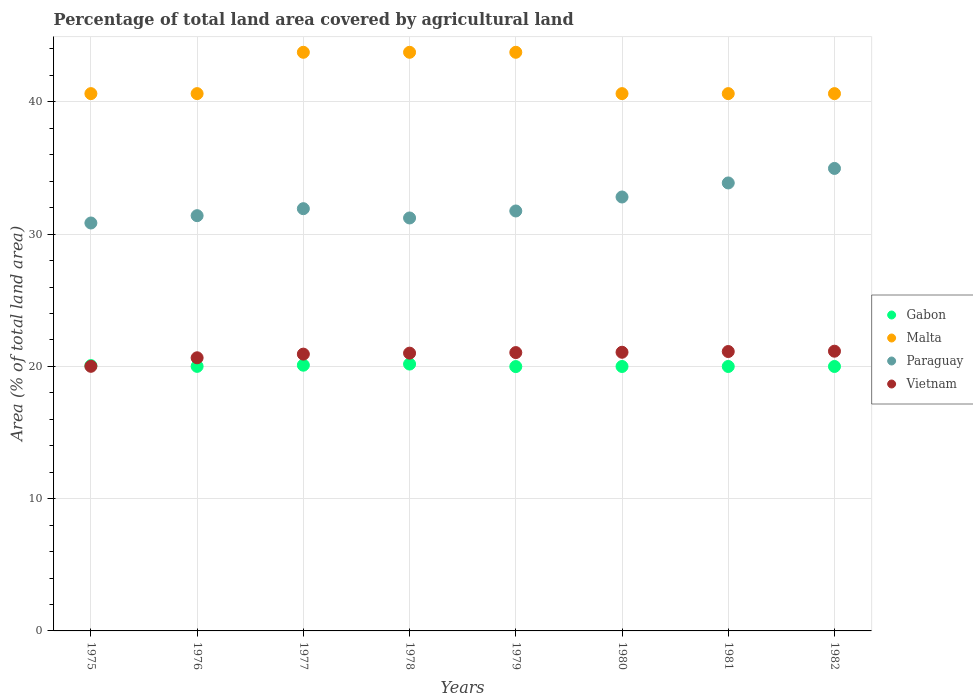How many different coloured dotlines are there?
Provide a succinct answer. 4. Is the number of dotlines equal to the number of legend labels?
Your response must be concise. Yes. What is the percentage of agricultural land in Paraguay in 1976?
Your answer should be very brief. 31.4. Across all years, what is the maximum percentage of agricultural land in Gabon?
Provide a short and direct response. 20.18. Across all years, what is the minimum percentage of agricultural land in Gabon?
Your answer should be compact. 19.99. In which year was the percentage of agricultural land in Vietnam maximum?
Offer a very short reply. 1982. In which year was the percentage of agricultural land in Paraguay minimum?
Offer a terse response. 1975. What is the total percentage of agricultural land in Paraguay in the graph?
Your answer should be very brief. 258.79. What is the difference between the percentage of agricultural land in Malta in 1976 and the percentage of agricultural land in Vietnam in 1980?
Ensure brevity in your answer.  19.56. What is the average percentage of agricultural land in Paraguay per year?
Your answer should be very brief. 32.35. In the year 1976, what is the difference between the percentage of agricultural land in Malta and percentage of agricultural land in Vietnam?
Provide a succinct answer. 19.97. In how many years, is the percentage of agricultural land in Vietnam greater than 4 %?
Offer a terse response. 8. What is the ratio of the percentage of agricultural land in Gabon in 1979 to that in 1982?
Your answer should be very brief. 1. Is the percentage of agricultural land in Vietnam in 1977 less than that in 1980?
Offer a very short reply. Yes. What is the difference between the highest and the second highest percentage of agricultural land in Paraguay?
Make the answer very short. 1.1. What is the difference between the highest and the lowest percentage of agricultural land in Paraguay?
Keep it short and to the point. 4.13. In how many years, is the percentage of agricultural land in Vietnam greater than the average percentage of agricultural land in Vietnam taken over all years?
Ensure brevity in your answer.  6. Is the sum of the percentage of agricultural land in Paraguay in 1977 and 1979 greater than the maximum percentage of agricultural land in Vietnam across all years?
Your answer should be very brief. Yes. Is it the case that in every year, the sum of the percentage of agricultural land in Malta and percentage of agricultural land in Gabon  is greater than the percentage of agricultural land in Vietnam?
Give a very brief answer. Yes. How many years are there in the graph?
Give a very brief answer. 8. What is the difference between two consecutive major ticks on the Y-axis?
Your response must be concise. 10. Does the graph contain any zero values?
Ensure brevity in your answer.  No. Does the graph contain grids?
Your response must be concise. Yes. How are the legend labels stacked?
Your answer should be compact. Vertical. What is the title of the graph?
Ensure brevity in your answer.  Percentage of total land area covered by agricultural land. Does "Slovenia" appear as one of the legend labels in the graph?
Your answer should be compact. No. What is the label or title of the X-axis?
Provide a succinct answer. Years. What is the label or title of the Y-axis?
Offer a very short reply. Area (% of total land area). What is the Area (% of total land area) of Gabon in 1975?
Your response must be concise. 20.06. What is the Area (% of total land area) of Malta in 1975?
Provide a succinct answer. 40.62. What is the Area (% of total land area) of Paraguay in 1975?
Provide a succinct answer. 30.84. What is the Area (% of total land area) in Vietnam in 1975?
Make the answer very short. 20.01. What is the Area (% of total land area) of Gabon in 1976?
Make the answer very short. 20. What is the Area (% of total land area) of Malta in 1976?
Keep it short and to the point. 40.62. What is the Area (% of total land area) of Paraguay in 1976?
Provide a succinct answer. 31.4. What is the Area (% of total land area) of Vietnam in 1976?
Your answer should be very brief. 20.65. What is the Area (% of total land area) in Gabon in 1977?
Offer a very short reply. 20.09. What is the Area (% of total land area) of Malta in 1977?
Your answer should be compact. 43.75. What is the Area (% of total land area) in Paraguay in 1977?
Make the answer very short. 31.93. What is the Area (% of total land area) of Vietnam in 1977?
Give a very brief answer. 20.93. What is the Area (% of total land area) in Gabon in 1978?
Provide a succinct answer. 20.18. What is the Area (% of total land area) of Malta in 1978?
Your response must be concise. 43.75. What is the Area (% of total land area) in Paraguay in 1978?
Provide a short and direct response. 31.22. What is the Area (% of total land area) of Vietnam in 1978?
Provide a succinct answer. 21. What is the Area (% of total land area) of Gabon in 1979?
Make the answer very short. 19.99. What is the Area (% of total land area) of Malta in 1979?
Offer a terse response. 43.75. What is the Area (% of total land area) of Paraguay in 1979?
Offer a very short reply. 31.75. What is the Area (% of total land area) of Vietnam in 1979?
Your answer should be very brief. 21.05. What is the Area (% of total land area) of Gabon in 1980?
Offer a terse response. 19.99. What is the Area (% of total land area) in Malta in 1980?
Ensure brevity in your answer.  40.62. What is the Area (% of total land area) in Paraguay in 1980?
Make the answer very short. 32.81. What is the Area (% of total land area) in Vietnam in 1980?
Your answer should be compact. 21.07. What is the Area (% of total land area) in Gabon in 1981?
Make the answer very short. 19.99. What is the Area (% of total land area) in Malta in 1981?
Your answer should be compact. 40.62. What is the Area (% of total land area) of Paraguay in 1981?
Make the answer very short. 33.87. What is the Area (% of total land area) of Vietnam in 1981?
Offer a very short reply. 21.13. What is the Area (% of total land area) of Gabon in 1982?
Provide a short and direct response. 19.99. What is the Area (% of total land area) in Malta in 1982?
Keep it short and to the point. 40.62. What is the Area (% of total land area) of Paraguay in 1982?
Your answer should be very brief. 34.97. What is the Area (% of total land area) in Vietnam in 1982?
Offer a very short reply. 21.15. Across all years, what is the maximum Area (% of total land area) of Gabon?
Offer a very short reply. 20.18. Across all years, what is the maximum Area (% of total land area) in Malta?
Give a very brief answer. 43.75. Across all years, what is the maximum Area (% of total land area) in Paraguay?
Keep it short and to the point. 34.97. Across all years, what is the maximum Area (% of total land area) of Vietnam?
Ensure brevity in your answer.  21.15. Across all years, what is the minimum Area (% of total land area) of Gabon?
Give a very brief answer. 19.99. Across all years, what is the minimum Area (% of total land area) of Malta?
Keep it short and to the point. 40.62. Across all years, what is the minimum Area (% of total land area) in Paraguay?
Keep it short and to the point. 30.84. Across all years, what is the minimum Area (% of total land area) in Vietnam?
Give a very brief answer. 20.01. What is the total Area (% of total land area) of Gabon in the graph?
Provide a short and direct response. 160.3. What is the total Area (% of total land area) of Malta in the graph?
Offer a terse response. 334.38. What is the total Area (% of total land area) of Paraguay in the graph?
Provide a succinct answer. 258.79. What is the total Area (% of total land area) in Vietnam in the graph?
Your response must be concise. 166.98. What is the difference between the Area (% of total land area) of Gabon in 1975 and that in 1976?
Offer a very short reply. 0.06. What is the difference between the Area (% of total land area) of Paraguay in 1975 and that in 1976?
Provide a short and direct response. -0.55. What is the difference between the Area (% of total land area) in Vietnam in 1975 and that in 1976?
Offer a very short reply. -0.65. What is the difference between the Area (% of total land area) in Gabon in 1975 and that in 1977?
Offer a very short reply. -0.03. What is the difference between the Area (% of total land area) in Malta in 1975 and that in 1977?
Give a very brief answer. -3.12. What is the difference between the Area (% of total land area) of Paraguay in 1975 and that in 1977?
Provide a short and direct response. -1.08. What is the difference between the Area (% of total land area) of Vietnam in 1975 and that in 1977?
Your answer should be very brief. -0.92. What is the difference between the Area (% of total land area) in Gabon in 1975 and that in 1978?
Ensure brevity in your answer.  -0.12. What is the difference between the Area (% of total land area) of Malta in 1975 and that in 1978?
Give a very brief answer. -3.12. What is the difference between the Area (% of total land area) in Paraguay in 1975 and that in 1978?
Offer a very short reply. -0.38. What is the difference between the Area (% of total land area) in Vietnam in 1975 and that in 1978?
Your response must be concise. -1. What is the difference between the Area (% of total land area) in Gabon in 1975 and that in 1979?
Keep it short and to the point. 0.07. What is the difference between the Area (% of total land area) of Malta in 1975 and that in 1979?
Provide a succinct answer. -3.12. What is the difference between the Area (% of total land area) of Paraguay in 1975 and that in 1979?
Offer a terse response. -0.91. What is the difference between the Area (% of total land area) in Vietnam in 1975 and that in 1979?
Ensure brevity in your answer.  -1.04. What is the difference between the Area (% of total land area) of Gabon in 1975 and that in 1980?
Offer a terse response. 0.07. What is the difference between the Area (% of total land area) in Paraguay in 1975 and that in 1980?
Offer a terse response. -1.97. What is the difference between the Area (% of total land area) of Vietnam in 1975 and that in 1980?
Ensure brevity in your answer.  -1.06. What is the difference between the Area (% of total land area) in Gabon in 1975 and that in 1981?
Offer a very short reply. 0.07. What is the difference between the Area (% of total land area) in Paraguay in 1975 and that in 1981?
Keep it short and to the point. -3.03. What is the difference between the Area (% of total land area) in Vietnam in 1975 and that in 1981?
Give a very brief answer. -1.12. What is the difference between the Area (% of total land area) in Gabon in 1975 and that in 1982?
Make the answer very short. 0.07. What is the difference between the Area (% of total land area) of Paraguay in 1975 and that in 1982?
Offer a very short reply. -4.13. What is the difference between the Area (% of total land area) of Vietnam in 1975 and that in 1982?
Offer a very short reply. -1.14. What is the difference between the Area (% of total land area) of Gabon in 1976 and that in 1977?
Give a very brief answer. -0.09. What is the difference between the Area (% of total land area) in Malta in 1976 and that in 1977?
Offer a terse response. -3.12. What is the difference between the Area (% of total land area) of Paraguay in 1976 and that in 1977?
Make the answer very short. -0.53. What is the difference between the Area (% of total land area) in Vietnam in 1976 and that in 1977?
Provide a short and direct response. -0.28. What is the difference between the Area (% of total land area) in Gabon in 1976 and that in 1978?
Your answer should be compact. -0.17. What is the difference between the Area (% of total land area) in Malta in 1976 and that in 1978?
Provide a succinct answer. -3.12. What is the difference between the Area (% of total land area) of Paraguay in 1976 and that in 1978?
Make the answer very short. 0.17. What is the difference between the Area (% of total land area) in Vietnam in 1976 and that in 1978?
Offer a very short reply. -0.35. What is the difference between the Area (% of total land area) of Gabon in 1976 and that in 1979?
Give a very brief answer. 0.02. What is the difference between the Area (% of total land area) in Malta in 1976 and that in 1979?
Your response must be concise. -3.12. What is the difference between the Area (% of total land area) in Paraguay in 1976 and that in 1979?
Offer a very short reply. -0.35. What is the difference between the Area (% of total land area) of Vietnam in 1976 and that in 1979?
Offer a very short reply. -0.39. What is the difference between the Area (% of total land area) in Gabon in 1976 and that in 1980?
Ensure brevity in your answer.  0.01. What is the difference between the Area (% of total land area) in Malta in 1976 and that in 1980?
Offer a terse response. 0. What is the difference between the Area (% of total land area) of Paraguay in 1976 and that in 1980?
Keep it short and to the point. -1.41. What is the difference between the Area (% of total land area) in Vietnam in 1976 and that in 1980?
Ensure brevity in your answer.  -0.42. What is the difference between the Area (% of total land area) in Gabon in 1976 and that in 1981?
Ensure brevity in your answer.  0.01. What is the difference between the Area (% of total land area) of Paraguay in 1976 and that in 1981?
Provide a succinct answer. -2.47. What is the difference between the Area (% of total land area) of Vietnam in 1976 and that in 1981?
Offer a terse response. -0.47. What is the difference between the Area (% of total land area) in Gabon in 1976 and that in 1982?
Make the answer very short. 0.01. What is the difference between the Area (% of total land area) in Paraguay in 1976 and that in 1982?
Your answer should be compact. -3.57. What is the difference between the Area (% of total land area) in Vietnam in 1976 and that in 1982?
Make the answer very short. -0.5. What is the difference between the Area (% of total land area) of Gabon in 1977 and that in 1978?
Your answer should be compact. -0.09. What is the difference between the Area (% of total land area) of Paraguay in 1977 and that in 1978?
Your answer should be compact. 0.7. What is the difference between the Area (% of total land area) of Vietnam in 1977 and that in 1978?
Give a very brief answer. -0.07. What is the difference between the Area (% of total land area) of Gabon in 1977 and that in 1979?
Make the answer very short. 0.1. What is the difference between the Area (% of total land area) of Paraguay in 1977 and that in 1979?
Offer a very short reply. 0.17. What is the difference between the Area (% of total land area) in Vietnam in 1977 and that in 1979?
Ensure brevity in your answer.  -0.12. What is the difference between the Area (% of total land area) in Gabon in 1977 and that in 1980?
Your response must be concise. 0.1. What is the difference between the Area (% of total land area) of Malta in 1977 and that in 1980?
Make the answer very short. 3.12. What is the difference between the Area (% of total land area) of Paraguay in 1977 and that in 1980?
Offer a very short reply. -0.88. What is the difference between the Area (% of total land area) of Vietnam in 1977 and that in 1980?
Your response must be concise. -0.14. What is the difference between the Area (% of total land area) in Gabon in 1977 and that in 1981?
Ensure brevity in your answer.  0.1. What is the difference between the Area (% of total land area) of Malta in 1977 and that in 1981?
Offer a terse response. 3.12. What is the difference between the Area (% of total land area) of Paraguay in 1977 and that in 1981?
Give a very brief answer. -1.95. What is the difference between the Area (% of total land area) in Vietnam in 1977 and that in 1981?
Your answer should be very brief. -0.2. What is the difference between the Area (% of total land area) of Gabon in 1977 and that in 1982?
Your answer should be very brief. 0.1. What is the difference between the Area (% of total land area) of Malta in 1977 and that in 1982?
Your answer should be very brief. 3.12. What is the difference between the Area (% of total land area) in Paraguay in 1977 and that in 1982?
Keep it short and to the point. -3.04. What is the difference between the Area (% of total land area) of Vietnam in 1977 and that in 1982?
Offer a very short reply. -0.22. What is the difference between the Area (% of total land area) in Gabon in 1978 and that in 1979?
Ensure brevity in your answer.  0.19. What is the difference between the Area (% of total land area) of Paraguay in 1978 and that in 1979?
Provide a short and direct response. -0.53. What is the difference between the Area (% of total land area) in Vietnam in 1978 and that in 1979?
Your answer should be very brief. -0.04. What is the difference between the Area (% of total land area) of Gabon in 1978 and that in 1980?
Your response must be concise. 0.18. What is the difference between the Area (% of total land area) in Malta in 1978 and that in 1980?
Give a very brief answer. 3.12. What is the difference between the Area (% of total land area) in Paraguay in 1978 and that in 1980?
Provide a short and direct response. -1.59. What is the difference between the Area (% of total land area) of Vietnam in 1978 and that in 1980?
Your answer should be compact. -0.07. What is the difference between the Area (% of total land area) of Gabon in 1978 and that in 1981?
Offer a very short reply. 0.18. What is the difference between the Area (% of total land area) in Malta in 1978 and that in 1981?
Give a very brief answer. 3.12. What is the difference between the Area (% of total land area) of Paraguay in 1978 and that in 1981?
Offer a terse response. -2.65. What is the difference between the Area (% of total land area) of Vietnam in 1978 and that in 1981?
Your response must be concise. -0.12. What is the difference between the Area (% of total land area) in Gabon in 1978 and that in 1982?
Ensure brevity in your answer.  0.18. What is the difference between the Area (% of total land area) in Malta in 1978 and that in 1982?
Offer a terse response. 3.12. What is the difference between the Area (% of total land area) of Paraguay in 1978 and that in 1982?
Keep it short and to the point. -3.75. What is the difference between the Area (% of total land area) in Vietnam in 1978 and that in 1982?
Your answer should be very brief. -0.15. What is the difference between the Area (% of total land area) of Gabon in 1979 and that in 1980?
Your answer should be very brief. -0.01. What is the difference between the Area (% of total land area) in Malta in 1979 and that in 1980?
Make the answer very short. 3.12. What is the difference between the Area (% of total land area) of Paraguay in 1979 and that in 1980?
Provide a succinct answer. -1.06. What is the difference between the Area (% of total land area) of Vietnam in 1979 and that in 1980?
Your answer should be very brief. -0.02. What is the difference between the Area (% of total land area) in Gabon in 1979 and that in 1981?
Give a very brief answer. -0.01. What is the difference between the Area (% of total land area) in Malta in 1979 and that in 1981?
Provide a short and direct response. 3.12. What is the difference between the Area (% of total land area) in Paraguay in 1979 and that in 1981?
Offer a very short reply. -2.12. What is the difference between the Area (% of total land area) of Vietnam in 1979 and that in 1981?
Your answer should be compact. -0.08. What is the difference between the Area (% of total land area) in Gabon in 1979 and that in 1982?
Your response must be concise. -0.01. What is the difference between the Area (% of total land area) in Malta in 1979 and that in 1982?
Your response must be concise. 3.12. What is the difference between the Area (% of total land area) in Paraguay in 1979 and that in 1982?
Your answer should be very brief. -3.22. What is the difference between the Area (% of total land area) in Vietnam in 1979 and that in 1982?
Your response must be concise. -0.1. What is the difference between the Area (% of total land area) in Gabon in 1980 and that in 1981?
Keep it short and to the point. 0. What is the difference between the Area (% of total land area) in Malta in 1980 and that in 1981?
Provide a succinct answer. 0. What is the difference between the Area (% of total land area) in Paraguay in 1980 and that in 1981?
Your answer should be very brief. -1.06. What is the difference between the Area (% of total land area) of Vietnam in 1980 and that in 1981?
Keep it short and to the point. -0.06. What is the difference between the Area (% of total land area) of Paraguay in 1980 and that in 1982?
Make the answer very short. -2.16. What is the difference between the Area (% of total land area) of Vietnam in 1980 and that in 1982?
Give a very brief answer. -0.08. What is the difference between the Area (% of total land area) of Gabon in 1981 and that in 1982?
Give a very brief answer. 0. What is the difference between the Area (% of total land area) of Paraguay in 1981 and that in 1982?
Make the answer very short. -1.1. What is the difference between the Area (% of total land area) of Vietnam in 1981 and that in 1982?
Your response must be concise. -0.02. What is the difference between the Area (% of total land area) of Gabon in 1975 and the Area (% of total land area) of Malta in 1976?
Keep it short and to the point. -20.56. What is the difference between the Area (% of total land area) in Gabon in 1975 and the Area (% of total land area) in Paraguay in 1976?
Offer a terse response. -11.34. What is the difference between the Area (% of total land area) of Gabon in 1975 and the Area (% of total land area) of Vietnam in 1976?
Keep it short and to the point. -0.59. What is the difference between the Area (% of total land area) of Malta in 1975 and the Area (% of total land area) of Paraguay in 1976?
Keep it short and to the point. 9.23. What is the difference between the Area (% of total land area) in Malta in 1975 and the Area (% of total land area) in Vietnam in 1976?
Keep it short and to the point. 19.97. What is the difference between the Area (% of total land area) of Paraguay in 1975 and the Area (% of total land area) of Vietnam in 1976?
Ensure brevity in your answer.  10.19. What is the difference between the Area (% of total land area) in Gabon in 1975 and the Area (% of total land area) in Malta in 1977?
Provide a short and direct response. -23.69. What is the difference between the Area (% of total land area) of Gabon in 1975 and the Area (% of total land area) of Paraguay in 1977?
Ensure brevity in your answer.  -11.87. What is the difference between the Area (% of total land area) of Gabon in 1975 and the Area (% of total land area) of Vietnam in 1977?
Your answer should be compact. -0.87. What is the difference between the Area (% of total land area) of Malta in 1975 and the Area (% of total land area) of Paraguay in 1977?
Your response must be concise. 8.7. What is the difference between the Area (% of total land area) in Malta in 1975 and the Area (% of total land area) in Vietnam in 1977?
Your answer should be compact. 19.7. What is the difference between the Area (% of total land area) of Paraguay in 1975 and the Area (% of total land area) of Vietnam in 1977?
Give a very brief answer. 9.91. What is the difference between the Area (% of total land area) in Gabon in 1975 and the Area (% of total land area) in Malta in 1978?
Ensure brevity in your answer.  -23.69. What is the difference between the Area (% of total land area) in Gabon in 1975 and the Area (% of total land area) in Paraguay in 1978?
Your response must be concise. -11.16. What is the difference between the Area (% of total land area) of Gabon in 1975 and the Area (% of total land area) of Vietnam in 1978?
Your answer should be very brief. -0.94. What is the difference between the Area (% of total land area) of Malta in 1975 and the Area (% of total land area) of Paraguay in 1978?
Keep it short and to the point. 9.4. What is the difference between the Area (% of total land area) in Malta in 1975 and the Area (% of total land area) in Vietnam in 1978?
Provide a succinct answer. 19.62. What is the difference between the Area (% of total land area) in Paraguay in 1975 and the Area (% of total land area) in Vietnam in 1978?
Offer a very short reply. 9.84. What is the difference between the Area (% of total land area) of Gabon in 1975 and the Area (% of total land area) of Malta in 1979?
Make the answer very short. -23.69. What is the difference between the Area (% of total land area) in Gabon in 1975 and the Area (% of total land area) in Paraguay in 1979?
Your response must be concise. -11.69. What is the difference between the Area (% of total land area) of Gabon in 1975 and the Area (% of total land area) of Vietnam in 1979?
Your answer should be compact. -0.98. What is the difference between the Area (% of total land area) in Malta in 1975 and the Area (% of total land area) in Paraguay in 1979?
Give a very brief answer. 8.87. What is the difference between the Area (% of total land area) in Malta in 1975 and the Area (% of total land area) in Vietnam in 1979?
Provide a succinct answer. 19.58. What is the difference between the Area (% of total land area) of Paraguay in 1975 and the Area (% of total land area) of Vietnam in 1979?
Keep it short and to the point. 9.8. What is the difference between the Area (% of total land area) in Gabon in 1975 and the Area (% of total land area) in Malta in 1980?
Provide a succinct answer. -20.56. What is the difference between the Area (% of total land area) of Gabon in 1975 and the Area (% of total land area) of Paraguay in 1980?
Your answer should be compact. -12.75. What is the difference between the Area (% of total land area) of Gabon in 1975 and the Area (% of total land area) of Vietnam in 1980?
Your answer should be compact. -1.01. What is the difference between the Area (% of total land area) in Malta in 1975 and the Area (% of total land area) in Paraguay in 1980?
Provide a short and direct response. 7.82. What is the difference between the Area (% of total land area) in Malta in 1975 and the Area (% of total land area) in Vietnam in 1980?
Offer a terse response. 19.56. What is the difference between the Area (% of total land area) of Paraguay in 1975 and the Area (% of total land area) of Vietnam in 1980?
Keep it short and to the point. 9.77. What is the difference between the Area (% of total land area) of Gabon in 1975 and the Area (% of total land area) of Malta in 1981?
Offer a very short reply. -20.56. What is the difference between the Area (% of total land area) in Gabon in 1975 and the Area (% of total land area) in Paraguay in 1981?
Your answer should be very brief. -13.81. What is the difference between the Area (% of total land area) of Gabon in 1975 and the Area (% of total land area) of Vietnam in 1981?
Offer a very short reply. -1.06. What is the difference between the Area (% of total land area) of Malta in 1975 and the Area (% of total land area) of Paraguay in 1981?
Provide a succinct answer. 6.75. What is the difference between the Area (% of total land area) of Malta in 1975 and the Area (% of total land area) of Vietnam in 1981?
Ensure brevity in your answer.  19.5. What is the difference between the Area (% of total land area) in Paraguay in 1975 and the Area (% of total land area) in Vietnam in 1981?
Offer a very short reply. 9.72. What is the difference between the Area (% of total land area) of Gabon in 1975 and the Area (% of total land area) of Malta in 1982?
Offer a very short reply. -20.56. What is the difference between the Area (% of total land area) of Gabon in 1975 and the Area (% of total land area) of Paraguay in 1982?
Provide a succinct answer. -14.91. What is the difference between the Area (% of total land area) of Gabon in 1975 and the Area (% of total land area) of Vietnam in 1982?
Ensure brevity in your answer.  -1.09. What is the difference between the Area (% of total land area) in Malta in 1975 and the Area (% of total land area) in Paraguay in 1982?
Your answer should be compact. 5.66. What is the difference between the Area (% of total land area) of Malta in 1975 and the Area (% of total land area) of Vietnam in 1982?
Offer a terse response. 19.48. What is the difference between the Area (% of total land area) in Paraguay in 1975 and the Area (% of total land area) in Vietnam in 1982?
Keep it short and to the point. 9.69. What is the difference between the Area (% of total land area) in Gabon in 1976 and the Area (% of total land area) in Malta in 1977?
Provide a short and direct response. -23.75. What is the difference between the Area (% of total land area) of Gabon in 1976 and the Area (% of total land area) of Paraguay in 1977?
Give a very brief answer. -11.92. What is the difference between the Area (% of total land area) in Gabon in 1976 and the Area (% of total land area) in Vietnam in 1977?
Offer a terse response. -0.93. What is the difference between the Area (% of total land area) of Malta in 1976 and the Area (% of total land area) of Paraguay in 1977?
Keep it short and to the point. 8.7. What is the difference between the Area (% of total land area) in Malta in 1976 and the Area (% of total land area) in Vietnam in 1977?
Provide a succinct answer. 19.7. What is the difference between the Area (% of total land area) of Paraguay in 1976 and the Area (% of total land area) of Vietnam in 1977?
Offer a terse response. 10.47. What is the difference between the Area (% of total land area) of Gabon in 1976 and the Area (% of total land area) of Malta in 1978?
Your answer should be compact. -23.75. What is the difference between the Area (% of total land area) of Gabon in 1976 and the Area (% of total land area) of Paraguay in 1978?
Offer a terse response. -11.22. What is the difference between the Area (% of total land area) of Gabon in 1976 and the Area (% of total land area) of Vietnam in 1978?
Make the answer very short. -1. What is the difference between the Area (% of total land area) in Malta in 1976 and the Area (% of total land area) in Paraguay in 1978?
Offer a terse response. 9.4. What is the difference between the Area (% of total land area) in Malta in 1976 and the Area (% of total land area) in Vietnam in 1978?
Ensure brevity in your answer.  19.62. What is the difference between the Area (% of total land area) of Paraguay in 1976 and the Area (% of total land area) of Vietnam in 1978?
Offer a terse response. 10.39. What is the difference between the Area (% of total land area) of Gabon in 1976 and the Area (% of total land area) of Malta in 1979?
Provide a succinct answer. -23.75. What is the difference between the Area (% of total land area) of Gabon in 1976 and the Area (% of total land area) of Paraguay in 1979?
Keep it short and to the point. -11.75. What is the difference between the Area (% of total land area) of Gabon in 1976 and the Area (% of total land area) of Vietnam in 1979?
Your answer should be compact. -1.04. What is the difference between the Area (% of total land area) in Malta in 1976 and the Area (% of total land area) in Paraguay in 1979?
Provide a short and direct response. 8.87. What is the difference between the Area (% of total land area) of Malta in 1976 and the Area (% of total land area) of Vietnam in 1979?
Provide a succinct answer. 19.58. What is the difference between the Area (% of total land area) in Paraguay in 1976 and the Area (% of total land area) in Vietnam in 1979?
Make the answer very short. 10.35. What is the difference between the Area (% of total land area) of Gabon in 1976 and the Area (% of total land area) of Malta in 1980?
Provide a short and direct response. -20.62. What is the difference between the Area (% of total land area) of Gabon in 1976 and the Area (% of total land area) of Paraguay in 1980?
Make the answer very short. -12.81. What is the difference between the Area (% of total land area) of Gabon in 1976 and the Area (% of total land area) of Vietnam in 1980?
Provide a succinct answer. -1.07. What is the difference between the Area (% of total land area) of Malta in 1976 and the Area (% of total land area) of Paraguay in 1980?
Your answer should be very brief. 7.82. What is the difference between the Area (% of total land area) of Malta in 1976 and the Area (% of total land area) of Vietnam in 1980?
Provide a succinct answer. 19.56. What is the difference between the Area (% of total land area) in Paraguay in 1976 and the Area (% of total land area) in Vietnam in 1980?
Make the answer very short. 10.33. What is the difference between the Area (% of total land area) in Gabon in 1976 and the Area (% of total land area) in Malta in 1981?
Ensure brevity in your answer.  -20.62. What is the difference between the Area (% of total land area) in Gabon in 1976 and the Area (% of total land area) in Paraguay in 1981?
Provide a succinct answer. -13.87. What is the difference between the Area (% of total land area) of Gabon in 1976 and the Area (% of total land area) of Vietnam in 1981?
Your answer should be very brief. -1.12. What is the difference between the Area (% of total land area) in Malta in 1976 and the Area (% of total land area) in Paraguay in 1981?
Give a very brief answer. 6.75. What is the difference between the Area (% of total land area) in Malta in 1976 and the Area (% of total land area) in Vietnam in 1981?
Make the answer very short. 19.5. What is the difference between the Area (% of total land area) in Paraguay in 1976 and the Area (% of total land area) in Vietnam in 1981?
Provide a succinct answer. 10.27. What is the difference between the Area (% of total land area) of Gabon in 1976 and the Area (% of total land area) of Malta in 1982?
Make the answer very short. -20.62. What is the difference between the Area (% of total land area) in Gabon in 1976 and the Area (% of total land area) in Paraguay in 1982?
Ensure brevity in your answer.  -14.97. What is the difference between the Area (% of total land area) of Gabon in 1976 and the Area (% of total land area) of Vietnam in 1982?
Your response must be concise. -1.15. What is the difference between the Area (% of total land area) in Malta in 1976 and the Area (% of total land area) in Paraguay in 1982?
Provide a succinct answer. 5.66. What is the difference between the Area (% of total land area) of Malta in 1976 and the Area (% of total land area) of Vietnam in 1982?
Your response must be concise. 19.48. What is the difference between the Area (% of total land area) in Paraguay in 1976 and the Area (% of total land area) in Vietnam in 1982?
Offer a terse response. 10.25. What is the difference between the Area (% of total land area) in Gabon in 1977 and the Area (% of total land area) in Malta in 1978?
Your answer should be very brief. -23.66. What is the difference between the Area (% of total land area) of Gabon in 1977 and the Area (% of total land area) of Paraguay in 1978?
Your answer should be compact. -11.13. What is the difference between the Area (% of total land area) of Gabon in 1977 and the Area (% of total land area) of Vietnam in 1978?
Offer a very short reply. -0.91. What is the difference between the Area (% of total land area) in Malta in 1977 and the Area (% of total land area) in Paraguay in 1978?
Your answer should be very brief. 12.53. What is the difference between the Area (% of total land area) in Malta in 1977 and the Area (% of total land area) in Vietnam in 1978?
Your response must be concise. 22.75. What is the difference between the Area (% of total land area) in Paraguay in 1977 and the Area (% of total land area) in Vietnam in 1978?
Your response must be concise. 10.92. What is the difference between the Area (% of total land area) of Gabon in 1977 and the Area (% of total land area) of Malta in 1979?
Provide a short and direct response. -23.66. What is the difference between the Area (% of total land area) of Gabon in 1977 and the Area (% of total land area) of Paraguay in 1979?
Keep it short and to the point. -11.66. What is the difference between the Area (% of total land area) in Gabon in 1977 and the Area (% of total land area) in Vietnam in 1979?
Provide a succinct answer. -0.95. What is the difference between the Area (% of total land area) of Malta in 1977 and the Area (% of total land area) of Paraguay in 1979?
Provide a succinct answer. 12. What is the difference between the Area (% of total land area) of Malta in 1977 and the Area (% of total land area) of Vietnam in 1979?
Give a very brief answer. 22.7. What is the difference between the Area (% of total land area) in Paraguay in 1977 and the Area (% of total land area) in Vietnam in 1979?
Your response must be concise. 10.88. What is the difference between the Area (% of total land area) in Gabon in 1977 and the Area (% of total land area) in Malta in 1980?
Provide a short and direct response. -20.53. What is the difference between the Area (% of total land area) of Gabon in 1977 and the Area (% of total land area) of Paraguay in 1980?
Keep it short and to the point. -12.72. What is the difference between the Area (% of total land area) of Gabon in 1977 and the Area (% of total land area) of Vietnam in 1980?
Your answer should be very brief. -0.98. What is the difference between the Area (% of total land area) of Malta in 1977 and the Area (% of total land area) of Paraguay in 1980?
Offer a terse response. 10.94. What is the difference between the Area (% of total land area) of Malta in 1977 and the Area (% of total land area) of Vietnam in 1980?
Ensure brevity in your answer.  22.68. What is the difference between the Area (% of total land area) of Paraguay in 1977 and the Area (% of total land area) of Vietnam in 1980?
Give a very brief answer. 10.86. What is the difference between the Area (% of total land area) in Gabon in 1977 and the Area (% of total land area) in Malta in 1981?
Provide a succinct answer. -20.53. What is the difference between the Area (% of total land area) in Gabon in 1977 and the Area (% of total land area) in Paraguay in 1981?
Make the answer very short. -13.78. What is the difference between the Area (% of total land area) in Gabon in 1977 and the Area (% of total land area) in Vietnam in 1981?
Your response must be concise. -1.03. What is the difference between the Area (% of total land area) in Malta in 1977 and the Area (% of total land area) in Paraguay in 1981?
Make the answer very short. 9.88. What is the difference between the Area (% of total land area) of Malta in 1977 and the Area (% of total land area) of Vietnam in 1981?
Provide a succinct answer. 22.62. What is the difference between the Area (% of total land area) of Paraguay in 1977 and the Area (% of total land area) of Vietnam in 1981?
Provide a succinct answer. 10.8. What is the difference between the Area (% of total land area) of Gabon in 1977 and the Area (% of total land area) of Malta in 1982?
Give a very brief answer. -20.53. What is the difference between the Area (% of total land area) in Gabon in 1977 and the Area (% of total land area) in Paraguay in 1982?
Provide a short and direct response. -14.88. What is the difference between the Area (% of total land area) of Gabon in 1977 and the Area (% of total land area) of Vietnam in 1982?
Give a very brief answer. -1.06. What is the difference between the Area (% of total land area) of Malta in 1977 and the Area (% of total land area) of Paraguay in 1982?
Provide a succinct answer. 8.78. What is the difference between the Area (% of total land area) of Malta in 1977 and the Area (% of total land area) of Vietnam in 1982?
Offer a very short reply. 22.6. What is the difference between the Area (% of total land area) in Paraguay in 1977 and the Area (% of total land area) in Vietnam in 1982?
Offer a terse response. 10.78. What is the difference between the Area (% of total land area) of Gabon in 1978 and the Area (% of total land area) of Malta in 1979?
Provide a succinct answer. -23.57. What is the difference between the Area (% of total land area) of Gabon in 1978 and the Area (% of total land area) of Paraguay in 1979?
Offer a terse response. -11.57. What is the difference between the Area (% of total land area) of Gabon in 1978 and the Area (% of total land area) of Vietnam in 1979?
Offer a very short reply. -0.87. What is the difference between the Area (% of total land area) in Malta in 1978 and the Area (% of total land area) in Paraguay in 1979?
Ensure brevity in your answer.  12. What is the difference between the Area (% of total land area) of Malta in 1978 and the Area (% of total land area) of Vietnam in 1979?
Make the answer very short. 22.7. What is the difference between the Area (% of total land area) in Paraguay in 1978 and the Area (% of total land area) in Vietnam in 1979?
Make the answer very short. 10.18. What is the difference between the Area (% of total land area) in Gabon in 1978 and the Area (% of total land area) in Malta in 1980?
Make the answer very short. -20.45. What is the difference between the Area (% of total land area) of Gabon in 1978 and the Area (% of total land area) of Paraguay in 1980?
Make the answer very short. -12.63. What is the difference between the Area (% of total land area) of Gabon in 1978 and the Area (% of total land area) of Vietnam in 1980?
Make the answer very short. -0.89. What is the difference between the Area (% of total land area) of Malta in 1978 and the Area (% of total land area) of Paraguay in 1980?
Your response must be concise. 10.94. What is the difference between the Area (% of total land area) in Malta in 1978 and the Area (% of total land area) in Vietnam in 1980?
Provide a short and direct response. 22.68. What is the difference between the Area (% of total land area) of Paraguay in 1978 and the Area (% of total land area) of Vietnam in 1980?
Offer a terse response. 10.15. What is the difference between the Area (% of total land area) in Gabon in 1978 and the Area (% of total land area) in Malta in 1981?
Offer a terse response. -20.45. What is the difference between the Area (% of total land area) of Gabon in 1978 and the Area (% of total land area) of Paraguay in 1981?
Your answer should be compact. -13.69. What is the difference between the Area (% of total land area) in Gabon in 1978 and the Area (% of total land area) in Vietnam in 1981?
Give a very brief answer. -0.95. What is the difference between the Area (% of total land area) in Malta in 1978 and the Area (% of total land area) in Paraguay in 1981?
Keep it short and to the point. 9.88. What is the difference between the Area (% of total land area) in Malta in 1978 and the Area (% of total land area) in Vietnam in 1981?
Your answer should be very brief. 22.62. What is the difference between the Area (% of total land area) in Paraguay in 1978 and the Area (% of total land area) in Vietnam in 1981?
Make the answer very short. 10.1. What is the difference between the Area (% of total land area) of Gabon in 1978 and the Area (% of total land area) of Malta in 1982?
Your answer should be compact. -20.45. What is the difference between the Area (% of total land area) of Gabon in 1978 and the Area (% of total land area) of Paraguay in 1982?
Your answer should be compact. -14.79. What is the difference between the Area (% of total land area) in Gabon in 1978 and the Area (% of total land area) in Vietnam in 1982?
Ensure brevity in your answer.  -0.97. What is the difference between the Area (% of total land area) of Malta in 1978 and the Area (% of total land area) of Paraguay in 1982?
Offer a very short reply. 8.78. What is the difference between the Area (% of total land area) of Malta in 1978 and the Area (% of total land area) of Vietnam in 1982?
Provide a short and direct response. 22.6. What is the difference between the Area (% of total land area) in Paraguay in 1978 and the Area (% of total land area) in Vietnam in 1982?
Ensure brevity in your answer.  10.07. What is the difference between the Area (% of total land area) of Gabon in 1979 and the Area (% of total land area) of Malta in 1980?
Your response must be concise. -20.64. What is the difference between the Area (% of total land area) in Gabon in 1979 and the Area (% of total land area) in Paraguay in 1980?
Offer a very short reply. -12.82. What is the difference between the Area (% of total land area) in Gabon in 1979 and the Area (% of total land area) in Vietnam in 1980?
Offer a very short reply. -1.08. What is the difference between the Area (% of total land area) in Malta in 1979 and the Area (% of total land area) in Paraguay in 1980?
Provide a succinct answer. 10.94. What is the difference between the Area (% of total land area) in Malta in 1979 and the Area (% of total land area) in Vietnam in 1980?
Ensure brevity in your answer.  22.68. What is the difference between the Area (% of total land area) of Paraguay in 1979 and the Area (% of total land area) of Vietnam in 1980?
Offer a very short reply. 10.68. What is the difference between the Area (% of total land area) in Gabon in 1979 and the Area (% of total land area) in Malta in 1981?
Your answer should be compact. -20.64. What is the difference between the Area (% of total land area) in Gabon in 1979 and the Area (% of total land area) in Paraguay in 1981?
Keep it short and to the point. -13.88. What is the difference between the Area (% of total land area) of Gabon in 1979 and the Area (% of total land area) of Vietnam in 1981?
Provide a succinct answer. -1.14. What is the difference between the Area (% of total land area) in Malta in 1979 and the Area (% of total land area) in Paraguay in 1981?
Make the answer very short. 9.88. What is the difference between the Area (% of total land area) of Malta in 1979 and the Area (% of total land area) of Vietnam in 1981?
Your answer should be very brief. 22.62. What is the difference between the Area (% of total land area) in Paraguay in 1979 and the Area (% of total land area) in Vietnam in 1981?
Provide a short and direct response. 10.63. What is the difference between the Area (% of total land area) in Gabon in 1979 and the Area (% of total land area) in Malta in 1982?
Your response must be concise. -20.64. What is the difference between the Area (% of total land area) of Gabon in 1979 and the Area (% of total land area) of Paraguay in 1982?
Provide a succinct answer. -14.98. What is the difference between the Area (% of total land area) in Gabon in 1979 and the Area (% of total land area) in Vietnam in 1982?
Make the answer very short. -1.16. What is the difference between the Area (% of total land area) in Malta in 1979 and the Area (% of total land area) in Paraguay in 1982?
Offer a terse response. 8.78. What is the difference between the Area (% of total land area) in Malta in 1979 and the Area (% of total land area) in Vietnam in 1982?
Make the answer very short. 22.6. What is the difference between the Area (% of total land area) in Paraguay in 1979 and the Area (% of total land area) in Vietnam in 1982?
Make the answer very short. 10.6. What is the difference between the Area (% of total land area) of Gabon in 1980 and the Area (% of total land area) of Malta in 1981?
Your answer should be very brief. -20.63. What is the difference between the Area (% of total land area) of Gabon in 1980 and the Area (% of total land area) of Paraguay in 1981?
Ensure brevity in your answer.  -13.88. What is the difference between the Area (% of total land area) of Gabon in 1980 and the Area (% of total land area) of Vietnam in 1981?
Provide a succinct answer. -1.13. What is the difference between the Area (% of total land area) in Malta in 1980 and the Area (% of total land area) in Paraguay in 1981?
Your answer should be compact. 6.75. What is the difference between the Area (% of total land area) of Malta in 1980 and the Area (% of total land area) of Vietnam in 1981?
Offer a very short reply. 19.5. What is the difference between the Area (% of total land area) of Paraguay in 1980 and the Area (% of total land area) of Vietnam in 1981?
Ensure brevity in your answer.  11.68. What is the difference between the Area (% of total land area) of Gabon in 1980 and the Area (% of total land area) of Malta in 1982?
Your answer should be very brief. -20.63. What is the difference between the Area (% of total land area) in Gabon in 1980 and the Area (% of total land area) in Paraguay in 1982?
Offer a very short reply. -14.97. What is the difference between the Area (% of total land area) in Gabon in 1980 and the Area (% of total land area) in Vietnam in 1982?
Make the answer very short. -1.16. What is the difference between the Area (% of total land area) of Malta in 1980 and the Area (% of total land area) of Paraguay in 1982?
Give a very brief answer. 5.66. What is the difference between the Area (% of total land area) of Malta in 1980 and the Area (% of total land area) of Vietnam in 1982?
Offer a terse response. 19.48. What is the difference between the Area (% of total land area) in Paraguay in 1980 and the Area (% of total land area) in Vietnam in 1982?
Make the answer very short. 11.66. What is the difference between the Area (% of total land area) of Gabon in 1981 and the Area (% of total land area) of Malta in 1982?
Your response must be concise. -20.63. What is the difference between the Area (% of total land area) of Gabon in 1981 and the Area (% of total land area) of Paraguay in 1982?
Make the answer very short. -14.97. What is the difference between the Area (% of total land area) of Gabon in 1981 and the Area (% of total land area) of Vietnam in 1982?
Keep it short and to the point. -1.16. What is the difference between the Area (% of total land area) of Malta in 1981 and the Area (% of total land area) of Paraguay in 1982?
Provide a short and direct response. 5.66. What is the difference between the Area (% of total land area) of Malta in 1981 and the Area (% of total land area) of Vietnam in 1982?
Your answer should be very brief. 19.48. What is the difference between the Area (% of total land area) in Paraguay in 1981 and the Area (% of total land area) in Vietnam in 1982?
Keep it short and to the point. 12.72. What is the average Area (% of total land area) in Gabon per year?
Ensure brevity in your answer.  20.04. What is the average Area (% of total land area) in Malta per year?
Offer a very short reply. 41.8. What is the average Area (% of total land area) of Paraguay per year?
Your response must be concise. 32.35. What is the average Area (% of total land area) in Vietnam per year?
Offer a very short reply. 20.87. In the year 1975, what is the difference between the Area (% of total land area) of Gabon and Area (% of total land area) of Malta?
Give a very brief answer. -20.56. In the year 1975, what is the difference between the Area (% of total land area) of Gabon and Area (% of total land area) of Paraguay?
Your answer should be very brief. -10.78. In the year 1975, what is the difference between the Area (% of total land area) of Gabon and Area (% of total land area) of Vietnam?
Your response must be concise. 0.05. In the year 1975, what is the difference between the Area (% of total land area) of Malta and Area (% of total land area) of Paraguay?
Give a very brief answer. 9.78. In the year 1975, what is the difference between the Area (% of total land area) in Malta and Area (% of total land area) in Vietnam?
Provide a short and direct response. 20.62. In the year 1975, what is the difference between the Area (% of total land area) of Paraguay and Area (% of total land area) of Vietnam?
Offer a very short reply. 10.84. In the year 1976, what is the difference between the Area (% of total land area) in Gabon and Area (% of total land area) in Malta?
Offer a very short reply. -20.62. In the year 1976, what is the difference between the Area (% of total land area) of Gabon and Area (% of total land area) of Paraguay?
Your response must be concise. -11.39. In the year 1976, what is the difference between the Area (% of total land area) of Gabon and Area (% of total land area) of Vietnam?
Ensure brevity in your answer.  -0.65. In the year 1976, what is the difference between the Area (% of total land area) in Malta and Area (% of total land area) in Paraguay?
Keep it short and to the point. 9.23. In the year 1976, what is the difference between the Area (% of total land area) in Malta and Area (% of total land area) in Vietnam?
Your response must be concise. 19.97. In the year 1976, what is the difference between the Area (% of total land area) in Paraguay and Area (% of total land area) in Vietnam?
Keep it short and to the point. 10.74. In the year 1977, what is the difference between the Area (% of total land area) in Gabon and Area (% of total land area) in Malta?
Ensure brevity in your answer.  -23.66. In the year 1977, what is the difference between the Area (% of total land area) of Gabon and Area (% of total land area) of Paraguay?
Your answer should be very brief. -11.83. In the year 1977, what is the difference between the Area (% of total land area) in Gabon and Area (% of total land area) in Vietnam?
Give a very brief answer. -0.84. In the year 1977, what is the difference between the Area (% of total land area) of Malta and Area (% of total land area) of Paraguay?
Keep it short and to the point. 11.82. In the year 1977, what is the difference between the Area (% of total land area) of Malta and Area (% of total land area) of Vietnam?
Ensure brevity in your answer.  22.82. In the year 1977, what is the difference between the Area (% of total land area) in Paraguay and Area (% of total land area) in Vietnam?
Provide a succinct answer. 11. In the year 1978, what is the difference between the Area (% of total land area) of Gabon and Area (% of total land area) of Malta?
Your answer should be compact. -23.57. In the year 1978, what is the difference between the Area (% of total land area) in Gabon and Area (% of total land area) in Paraguay?
Give a very brief answer. -11.05. In the year 1978, what is the difference between the Area (% of total land area) of Gabon and Area (% of total land area) of Vietnam?
Give a very brief answer. -0.83. In the year 1978, what is the difference between the Area (% of total land area) in Malta and Area (% of total land area) in Paraguay?
Give a very brief answer. 12.53. In the year 1978, what is the difference between the Area (% of total land area) of Malta and Area (% of total land area) of Vietnam?
Your answer should be very brief. 22.75. In the year 1978, what is the difference between the Area (% of total land area) in Paraguay and Area (% of total land area) in Vietnam?
Keep it short and to the point. 10.22. In the year 1979, what is the difference between the Area (% of total land area) of Gabon and Area (% of total land area) of Malta?
Provide a short and direct response. -23.76. In the year 1979, what is the difference between the Area (% of total land area) of Gabon and Area (% of total land area) of Paraguay?
Give a very brief answer. -11.77. In the year 1979, what is the difference between the Area (% of total land area) in Gabon and Area (% of total land area) in Vietnam?
Offer a very short reply. -1.06. In the year 1979, what is the difference between the Area (% of total land area) of Malta and Area (% of total land area) of Paraguay?
Keep it short and to the point. 12. In the year 1979, what is the difference between the Area (% of total land area) in Malta and Area (% of total land area) in Vietnam?
Ensure brevity in your answer.  22.7. In the year 1979, what is the difference between the Area (% of total land area) in Paraguay and Area (% of total land area) in Vietnam?
Your answer should be very brief. 10.71. In the year 1980, what is the difference between the Area (% of total land area) of Gabon and Area (% of total land area) of Malta?
Offer a terse response. -20.63. In the year 1980, what is the difference between the Area (% of total land area) of Gabon and Area (% of total land area) of Paraguay?
Provide a succinct answer. -12.81. In the year 1980, what is the difference between the Area (% of total land area) in Gabon and Area (% of total land area) in Vietnam?
Provide a short and direct response. -1.08. In the year 1980, what is the difference between the Area (% of total land area) of Malta and Area (% of total land area) of Paraguay?
Offer a very short reply. 7.82. In the year 1980, what is the difference between the Area (% of total land area) of Malta and Area (% of total land area) of Vietnam?
Offer a very short reply. 19.56. In the year 1980, what is the difference between the Area (% of total land area) in Paraguay and Area (% of total land area) in Vietnam?
Provide a short and direct response. 11.74. In the year 1981, what is the difference between the Area (% of total land area) of Gabon and Area (% of total land area) of Malta?
Offer a very short reply. -20.63. In the year 1981, what is the difference between the Area (% of total land area) in Gabon and Area (% of total land area) in Paraguay?
Your answer should be compact. -13.88. In the year 1981, what is the difference between the Area (% of total land area) of Gabon and Area (% of total land area) of Vietnam?
Keep it short and to the point. -1.13. In the year 1981, what is the difference between the Area (% of total land area) of Malta and Area (% of total land area) of Paraguay?
Make the answer very short. 6.75. In the year 1981, what is the difference between the Area (% of total land area) in Malta and Area (% of total land area) in Vietnam?
Keep it short and to the point. 19.5. In the year 1981, what is the difference between the Area (% of total land area) of Paraguay and Area (% of total land area) of Vietnam?
Your answer should be compact. 12.75. In the year 1982, what is the difference between the Area (% of total land area) in Gabon and Area (% of total land area) in Malta?
Your answer should be very brief. -20.63. In the year 1982, what is the difference between the Area (% of total land area) in Gabon and Area (% of total land area) in Paraguay?
Offer a very short reply. -14.97. In the year 1982, what is the difference between the Area (% of total land area) of Gabon and Area (% of total land area) of Vietnam?
Offer a terse response. -1.16. In the year 1982, what is the difference between the Area (% of total land area) of Malta and Area (% of total land area) of Paraguay?
Your response must be concise. 5.66. In the year 1982, what is the difference between the Area (% of total land area) of Malta and Area (% of total land area) of Vietnam?
Your answer should be compact. 19.48. In the year 1982, what is the difference between the Area (% of total land area) of Paraguay and Area (% of total land area) of Vietnam?
Provide a short and direct response. 13.82. What is the ratio of the Area (% of total land area) of Malta in 1975 to that in 1976?
Keep it short and to the point. 1. What is the ratio of the Area (% of total land area) of Paraguay in 1975 to that in 1976?
Provide a succinct answer. 0.98. What is the ratio of the Area (% of total land area) of Vietnam in 1975 to that in 1976?
Your response must be concise. 0.97. What is the ratio of the Area (% of total land area) in Paraguay in 1975 to that in 1977?
Ensure brevity in your answer.  0.97. What is the ratio of the Area (% of total land area) of Vietnam in 1975 to that in 1977?
Give a very brief answer. 0.96. What is the ratio of the Area (% of total land area) in Gabon in 1975 to that in 1978?
Your response must be concise. 0.99. What is the ratio of the Area (% of total land area) of Malta in 1975 to that in 1978?
Offer a very short reply. 0.93. What is the ratio of the Area (% of total land area) of Vietnam in 1975 to that in 1978?
Your answer should be compact. 0.95. What is the ratio of the Area (% of total land area) in Gabon in 1975 to that in 1979?
Make the answer very short. 1. What is the ratio of the Area (% of total land area) in Paraguay in 1975 to that in 1979?
Make the answer very short. 0.97. What is the ratio of the Area (% of total land area) in Vietnam in 1975 to that in 1979?
Your answer should be compact. 0.95. What is the ratio of the Area (% of total land area) in Gabon in 1975 to that in 1980?
Ensure brevity in your answer.  1. What is the ratio of the Area (% of total land area) in Malta in 1975 to that in 1980?
Keep it short and to the point. 1. What is the ratio of the Area (% of total land area) in Paraguay in 1975 to that in 1980?
Provide a succinct answer. 0.94. What is the ratio of the Area (% of total land area) of Vietnam in 1975 to that in 1980?
Give a very brief answer. 0.95. What is the ratio of the Area (% of total land area) in Malta in 1975 to that in 1981?
Give a very brief answer. 1. What is the ratio of the Area (% of total land area) in Paraguay in 1975 to that in 1981?
Your answer should be compact. 0.91. What is the ratio of the Area (% of total land area) in Vietnam in 1975 to that in 1981?
Provide a succinct answer. 0.95. What is the ratio of the Area (% of total land area) of Gabon in 1975 to that in 1982?
Offer a very short reply. 1. What is the ratio of the Area (% of total land area) in Malta in 1975 to that in 1982?
Offer a very short reply. 1. What is the ratio of the Area (% of total land area) of Paraguay in 1975 to that in 1982?
Make the answer very short. 0.88. What is the ratio of the Area (% of total land area) of Vietnam in 1975 to that in 1982?
Keep it short and to the point. 0.95. What is the ratio of the Area (% of total land area) of Malta in 1976 to that in 1977?
Provide a short and direct response. 0.93. What is the ratio of the Area (% of total land area) in Paraguay in 1976 to that in 1977?
Provide a short and direct response. 0.98. What is the ratio of the Area (% of total land area) in Vietnam in 1976 to that in 1977?
Offer a very short reply. 0.99. What is the ratio of the Area (% of total land area) of Paraguay in 1976 to that in 1978?
Your answer should be very brief. 1.01. What is the ratio of the Area (% of total land area) in Vietnam in 1976 to that in 1978?
Your response must be concise. 0.98. What is the ratio of the Area (% of total land area) in Gabon in 1976 to that in 1979?
Offer a very short reply. 1. What is the ratio of the Area (% of total land area) of Vietnam in 1976 to that in 1979?
Offer a terse response. 0.98. What is the ratio of the Area (% of total land area) in Paraguay in 1976 to that in 1980?
Keep it short and to the point. 0.96. What is the ratio of the Area (% of total land area) in Vietnam in 1976 to that in 1980?
Offer a terse response. 0.98. What is the ratio of the Area (% of total land area) in Gabon in 1976 to that in 1981?
Your answer should be very brief. 1. What is the ratio of the Area (% of total land area) of Malta in 1976 to that in 1981?
Provide a succinct answer. 1. What is the ratio of the Area (% of total land area) in Paraguay in 1976 to that in 1981?
Offer a very short reply. 0.93. What is the ratio of the Area (% of total land area) in Vietnam in 1976 to that in 1981?
Give a very brief answer. 0.98. What is the ratio of the Area (% of total land area) in Paraguay in 1976 to that in 1982?
Your answer should be very brief. 0.9. What is the ratio of the Area (% of total land area) of Vietnam in 1976 to that in 1982?
Provide a succinct answer. 0.98. What is the ratio of the Area (% of total land area) in Paraguay in 1977 to that in 1978?
Ensure brevity in your answer.  1.02. What is the ratio of the Area (% of total land area) in Malta in 1977 to that in 1979?
Offer a very short reply. 1. What is the ratio of the Area (% of total land area) in Vietnam in 1977 to that in 1979?
Provide a short and direct response. 0.99. What is the ratio of the Area (% of total land area) in Paraguay in 1977 to that in 1980?
Keep it short and to the point. 0.97. What is the ratio of the Area (% of total land area) in Gabon in 1977 to that in 1981?
Your response must be concise. 1. What is the ratio of the Area (% of total land area) of Malta in 1977 to that in 1981?
Your answer should be compact. 1.08. What is the ratio of the Area (% of total land area) in Paraguay in 1977 to that in 1981?
Your response must be concise. 0.94. What is the ratio of the Area (% of total land area) of Gabon in 1978 to that in 1979?
Keep it short and to the point. 1.01. What is the ratio of the Area (% of total land area) in Malta in 1978 to that in 1979?
Offer a very short reply. 1. What is the ratio of the Area (% of total land area) in Paraguay in 1978 to that in 1979?
Ensure brevity in your answer.  0.98. What is the ratio of the Area (% of total land area) of Gabon in 1978 to that in 1980?
Provide a short and direct response. 1.01. What is the ratio of the Area (% of total land area) in Paraguay in 1978 to that in 1980?
Your answer should be compact. 0.95. What is the ratio of the Area (% of total land area) of Gabon in 1978 to that in 1981?
Give a very brief answer. 1.01. What is the ratio of the Area (% of total land area) in Malta in 1978 to that in 1981?
Keep it short and to the point. 1.08. What is the ratio of the Area (% of total land area) in Paraguay in 1978 to that in 1981?
Your answer should be very brief. 0.92. What is the ratio of the Area (% of total land area) in Gabon in 1978 to that in 1982?
Provide a short and direct response. 1.01. What is the ratio of the Area (% of total land area) of Paraguay in 1978 to that in 1982?
Your answer should be compact. 0.89. What is the ratio of the Area (% of total land area) in Vietnam in 1978 to that in 1982?
Keep it short and to the point. 0.99. What is the ratio of the Area (% of total land area) of Paraguay in 1979 to that in 1980?
Ensure brevity in your answer.  0.97. What is the ratio of the Area (% of total land area) in Gabon in 1979 to that in 1981?
Ensure brevity in your answer.  1. What is the ratio of the Area (% of total land area) in Malta in 1979 to that in 1981?
Your response must be concise. 1.08. What is the ratio of the Area (% of total land area) in Paraguay in 1979 to that in 1981?
Offer a terse response. 0.94. What is the ratio of the Area (% of total land area) in Vietnam in 1979 to that in 1981?
Offer a very short reply. 1. What is the ratio of the Area (% of total land area) in Malta in 1979 to that in 1982?
Offer a terse response. 1.08. What is the ratio of the Area (% of total land area) in Paraguay in 1979 to that in 1982?
Your answer should be very brief. 0.91. What is the ratio of the Area (% of total land area) of Malta in 1980 to that in 1981?
Your response must be concise. 1. What is the ratio of the Area (% of total land area) in Paraguay in 1980 to that in 1981?
Make the answer very short. 0.97. What is the ratio of the Area (% of total land area) of Paraguay in 1980 to that in 1982?
Your answer should be compact. 0.94. What is the ratio of the Area (% of total land area) of Gabon in 1981 to that in 1982?
Ensure brevity in your answer.  1. What is the ratio of the Area (% of total land area) in Malta in 1981 to that in 1982?
Ensure brevity in your answer.  1. What is the ratio of the Area (% of total land area) of Paraguay in 1981 to that in 1982?
Keep it short and to the point. 0.97. What is the difference between the highest and the second highest Area (% of total land area) in Gabon?
Your response must be concise. 0.09. What is the difference between the highest and the second highest Area (% of total land area) of Malta?
Provide a short and direct response. 0. What is the difference between the highest and the second highest Area (% of total land area) in Paraguay?
Make the answer very short. 1.1. What is the difference between the highest and the second highest Area (% of total land area) in Vietnam?
Ensure brevity in your answer.  0.02. What is the difference between the highest and the lowest Area (% of total land area) in Gabon?
Offer a very short reply. 0.19. What is the difference between the highest and the lowest Area (% of total land area) in Malta?
Keep it short and to the point. 3.12. What is the difference between the highest and the lowest Area (% of total land area) of Paraguay?
Offer a terse response. 4.13. 